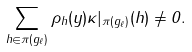Convert formula to latex. <formula><loc_0><loc_0><loc_500><loc_500>\sum _ { h \in \pi ( g _ { \ell } ) } \rho _ { h } ( y ) \kappa | _ { \pi ( g _ { \ell } ) } ( h ) \not = 0 .</formula> 